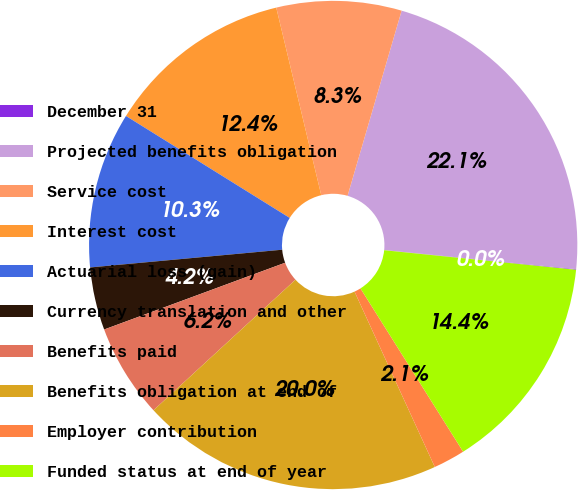<chart> <loc_0><loc_0><loc_500><loc_500><pie_chart><fcel>December 31<fcel>Projected benefits obligation<fcel>Service cost<fcel>Interest cost<fcel>Actuarial loss (gain)<fcel>Currency translation and other<fcel>Benefits paid<fcel>Benefits obligation at end of<fcel>Employer contribution<fcel>Funded status at end of year<nl><fcel>0.04%<fcel>22.06%<fcel>8.27%<fcel>12.39%<fcel>10.33%<fcel>4.16%<fcel>6.21%<fcel>20.0%<fcel>2.1%<fcel>14.45%<nl></chart> 